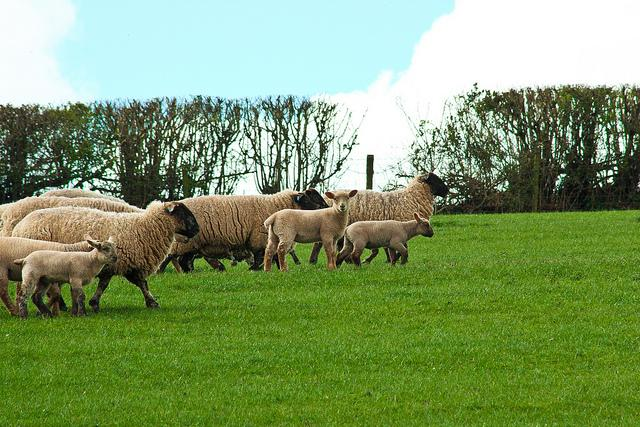Why are some of the animals smaller than other? Please explain your reasoning. age. They are babies. babies are younger than the adults. 